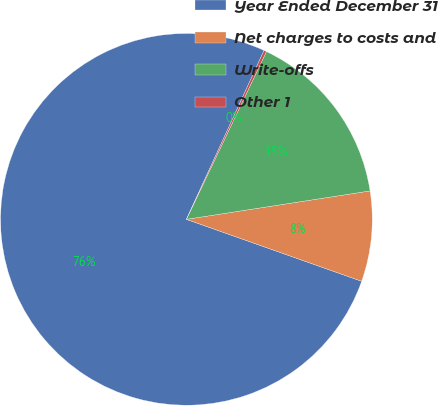Convert chart to OTSL. <chart><loc_0><loc_0><loc_500><loc_500><pie_chart><fcel>Year Ended December 31<fcel>Net charges to costs and<fcel>Write-offs<fcel>Other 1<nl><fcel>76.45%<fcel>7.85%<fcel>15.47%<fcel>0.23%<nl></chart> 